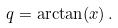<formula> <loc_0><loc_0><loc_500><loc_500>q = \arctan ( x ) \, .</formula> 